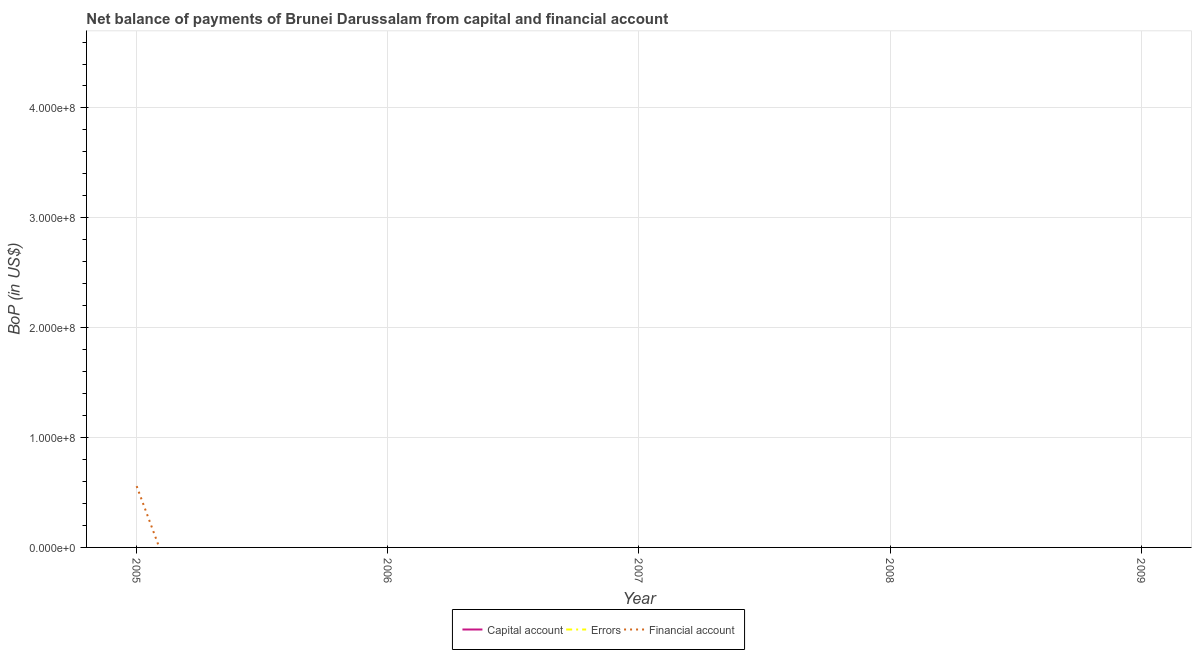How many different coloured lines are there?
Your response must be concise. 1. Is the number of lines equal to the number of legend labels?
Your answer should be very brief. No. What is the amount of errors in 2006?
Your response must be concise. 0. Across all years, what is the maximum amount of financial account?
Your response must be concise. 5.58e+07. Across all years, what is the minimum amount of financial account?
Offer a very short reply. 0. In which year was the amount of financial account maximum?
Provide a short and direct response. 2005. What is the difference between the amount of errors in 2005 and the amount of net capital account in 2009?
Ensure brevity in your answer.  0. What is the average amount of errors per year?
Give a very brief answer. 0. In how many years, is the amount of net capital account greater than 260000000 US$?
Give a very brief answer. 0. What is the difference between the highest and the lowest amount of financial account?
Provide a succinct answer. 5.58e+07. In how many years, is the amount of errors greater than the average amount of errors taken over all years?
Your answer should be compact. 0. Does the amount of net capital account monotonically increase over the years?
Your answer should be very brief. No. Is the amount of errors strictly less than the amount of financial account over the years?
Offer a very short reply. Yes. What is the difference between two consecutive major ticks on the Y-axis?
Offer a very short reply. 1.00e+08. How are the legend labels stacked?
Provide a short and direct response. Horizontal. What is the title of the graph?
Keep it short and to the point. Net balance of payments of Brunei Darussalam from capital and financial account. What is the label or title of the Y-axis?
Give a very brief answer. BoP (in US$). What is the BoP (in US$) in Capital account in 2005?
Your answer should be compact. 0. What is the BoP (in US$) in Financial account in 2005?
Offer a very short reply. 5.58e+07. What is the BoP (in US$) of Capital account in 2006?
Your answer should be compact. 0. What is the BoP (in US$) in Errors in 2006?
Offer a very short reply. 0. What is the BoP (in US$) in Financial account in 2006?
Your response must be concise. 0. What is the BoP (in US$) in Errors in 2007?
Ensure brevity in your answer.  0. What is the BoP (in US$) in Financial account in 2007?
Give a very brief answer. 0. What is the BoP (in US$) in Capital account in 2008?
Ensure brevity in your answer.  0. What is the BoP (in US$) of Errors in 2008?
Your answer should be very brief. 0. What is the BoP (in US$) in Financial account in 2008?
Ensure brevity in your answer.  0. What is the BoP (in US$) of Errors in 2009?
Offer a very short reply. 0. What is the BoP (in US$) of Financial account in 2009?
Provide a succinct answer. 0. Across all years, what is the maximum BoP (in US$) in Financial account?
Give a very brief answer. 5.58e+07. Across all years, what is the minimum BoP (in US$) of Financial account?
Your response must be concise. 0. What is the total BoP (in US$) in Capital account in the graph?
Make the answer very short. 0. What is the total BoP (in US$) of Errors in the graph?
Your answer should be compact. 0. What is the total BoP (in US$) of Financial account in the graph?
Your answer should be very brief. 5.58e+07. What is the average BoP (in US$) in Capital account per year?
Ensure brevity in your answer.  0. What is the average BoP (in US$) in Financial account per year?
Offer a terse response. 1.12e+07. What is the difference between the highest and the lowest BoP (in US$) of Financial account?
Your answer should be compact. 5.58e+07. 